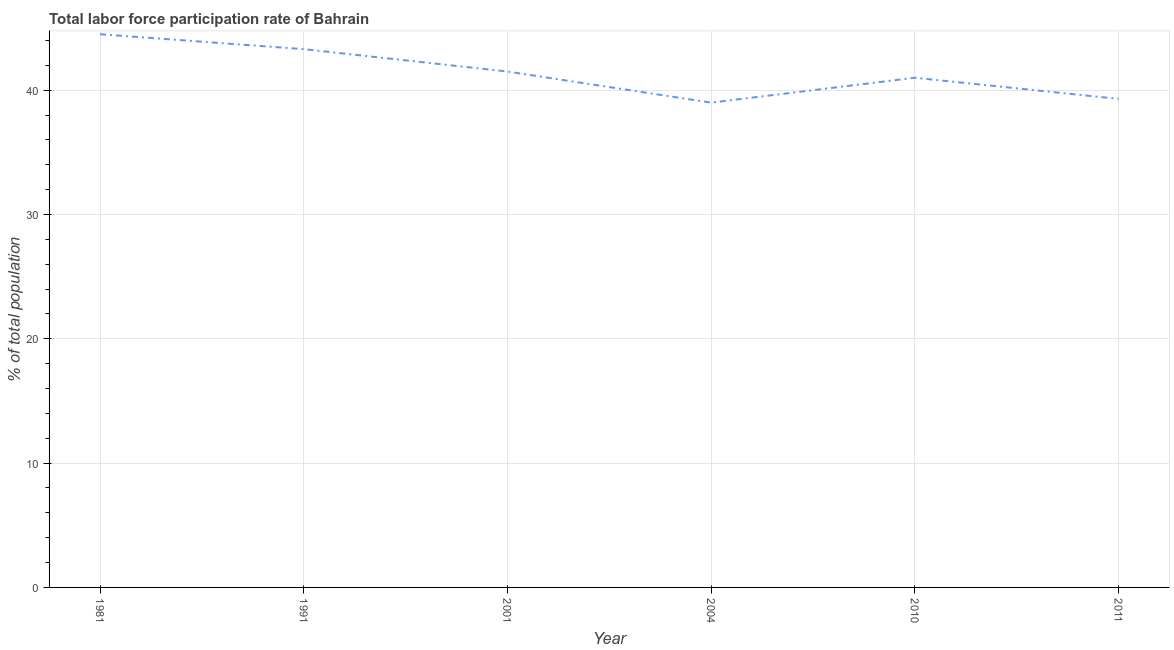What is the total labor force participation rate in 1981?
Make the answer very short. 44.5. Across all years, what is the maximum total labor force participation rate?
Offer a very short reply. 44.5. Across all years, what is the minimum total labor force participation rate?
Make the answer very short. 39. In which year was the total labor force participation rate maximum?
Keep it short and to the point. 1981. In which year was the total labor force participation rate minimum?
Your answer should be very brief. 2004. What is the sum of the total labor force participation rate?
Keep it short and to the point. 248.6. What is the difference between the total labor force participation rate in 1991 and 2004?
Ensure brevity in your answer.  4.3. What is the average total labor force participation rate per year?
Give a very brief answer. 41.43. What is the median total labor force participation rate?
Your answer should be compact. 41.25. In how many years, is the total labor force participation rate greater than 32 %?
Make the answer very short. 6. What is the ratio of the total labor force participation rate in 2010 to that in 2011?
Your response must be concise. 1.04. Is the total labor force participation rate in 2010 less than that in 2011?
Make the answer very short. No. Is the difference between the total labor force participation rate in 2004 and 2011 greater than the difference between any two years?
Offer a very short reply. No. What is the difference between the highest and the second highest total labor force participation rate?
Your answer should be very brief. 1.2. What is the difference between the highest and the lowest total labor force participation rate?
Ensure brevity in your answer.  5.5. In how many years, is the total labor force participation rate greater than the average total labor force participation rate taken over all years?
Ensure brevity in your answer.  3. How many lines are there?
Provide a short and direct response. 1. Does the graph contain any zero values?
Offer a terse response. No. What is the title of the graph?
Give a very brief answer. Total labor force participation rate of Bahrain. What is the label or title of the X-axis?
Make the answer very short. Year. What is the label or title of the Y-axis?
Ensure brevity in your answer.  % of total population. What is the % of total population of 1981?
Keep it short and to the point. 44.5. What is the % of total population of 1991?
Give a very brief answer. 43.3. What is the % of total population of 2001?
Your answer should be very brief. 41.5. What is the % of total population of 2011?
Provide a short and direct response. 39.3. What is the difference between the % of total population in 1981 and 2001?
Keep it short and to the point. 3. What is the difference between the % of total population in 1981 and 2011?
Make the answer very short. 5.2. What is the difference between the % of total population in 1991 and 2001?
Ensure brevity in your answer.  1.8. What is the difference between the % of total population in 1991 and 2004?
Offer a very short reply. 4.3. What is the difference between the % of total population in 1991 and 2010?
Make the answer very short. 2.3. What is the difference between the % of total population in 1991 and 2011?
Provide a succinct answer. 4. What is the difference between the % of total population in 2004 and 2010?
Offer a very short reply. -2. What is the difference between the % of total population in 2004 and 2011?
Ensure brevity in your answer.  -0.3. What is the difference between the % of total population in 2010 and 2011?
Your answer should be very brief. 1.7. What is the ratio of the % of total population in 1981 to that in 1991?
Provide a succinct answer. 1.03. What is the ratio of the % of total population in 1981 to that in 2001?
Keep it short and to the point. 1.07. What is the ratio of the % of total population in 1981 to that in 2004?
Make the answer very short. 1.14. What is the ratio of the % of total population in 1981 to that in 2010?
Offer a terse response. 1.08. What is the ratio of the % of total population in 1981 to that in 2011?
Provide a succinct answer. 1.13. What is the ratio of the % of total population in 1991 to that in 2001?
Give a very brief answer. 1.04. What is the ratio of the % of total population in 1991 to that in 2004?
Your response must be concise. 1.11. What is the ratio of the % of total population in 1991 to that in 2010?
Your answer should be very brief. 1.06. What is the ratio of the % of total population in 1991 to that in 2011?
Your response must be concise. 1.1. What is the ratio of the % of total population in 2001 to that in 2004?
Offer a very short reply. 1.06. What is the ratio of the % of total population in 2001 to that in 2011?
Provide a short and direct response. 1.06. What is the ratio of the % of total population in 2004 to that in 2010?
Provide a succinct answer. 0.95. What is the ratio of the % of total population in 2010 to that in 2011?
Keep it short and to the point. 1.04. 